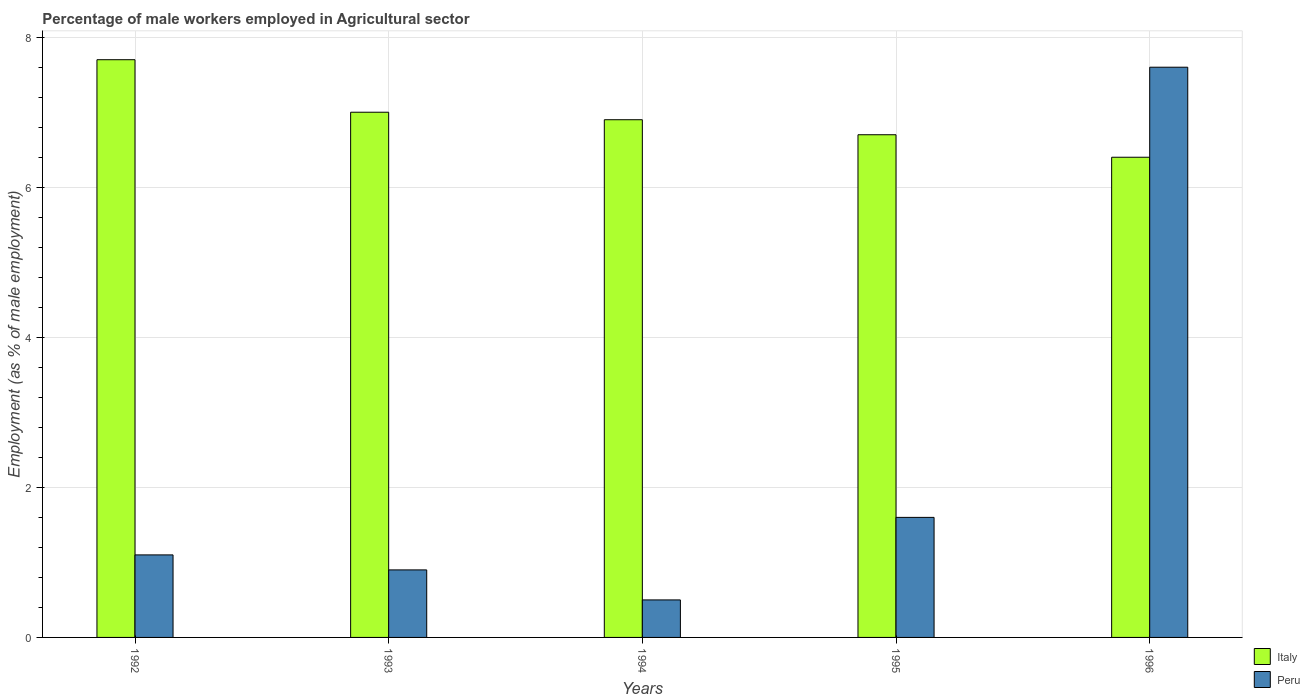How many different coloured bars are there?
Make the answer very short. 2. How many groups of bars are there?
Your response must be concise. 5. How many bars are there on the 4th tick from the left?
Offer a very short reply. 2. How many bars are there on the 4th tick from the right?
Offer a very short reply. 2. In how many cases, is the number of bars for a given year not equal to the number of legend labels?
Your answer should be compact. 0. Across all years, what is the maximum percentage of male workers employed in Agricultural sector in Italy?
Your response must be concise. 7.7. Across all years, what is the minimum percentage of male workers employed in Agricultural sector in Peru?
Give a very brief answer. 0.5. In which year was the percentage of male workers employed in Agricultural sector in Italy maximum?
Offer a very short reply. 1992. In which year was the percentage of male workers employed in Agricultural sector in Peru minimum?
Offer a terse response. 1994. What is the total percentage of male workers employed in Agricultural sector in Italy in the graph?
Ensure brevity in your answer.  34.7. What is the difference between the percentage of male workers employed in Agricultural sector in Peru in 1992 and that in 1994?
Make the answer very short. 0.6. What is the difference between the percentage of male workers employed in Agricultural sector in Italy in 1996 and the percentage of male workers employed in Agricultural sector in Peru in 1994?
Make the answer very short. 5.9. What is the average percentage of male workers employed in Agricultural sector in Peru per year?
Your answer should be very brief. 2.34. In the year 1993, what is the difference between the percentage of male workers employed in Agricultural sector in Peru and percentage of male workers employed in Agricultural sector in Italy?
Offer a terse response. -6.1. In how many years, is the percentage of male workers employed in Agricultural sector in Italy greater than 0.4 %?
Provide a succinct answer. 5. What is the ratio of the percentage of male workers employed in Agricultural sector in Peru in 1992 to that in 1996?
Make the answer very short. 0.14. What is the difference between the highest and the second highest percentage of male workers employed in Agricultural sector in Peru?
Your answer should be very brief. 6. What is the difference between the highest and the lowest percentage of male workers employed in Agricultural sector in Italy?
Your response must be concise. 1.3. What does the 1st bar from the right in 1992 represents?
Offer a terse response. Peru. Are all the bars in the graph horizontal?
Your response must be concise. No. How many years are there in the graph?
Provide a short and direct response. 5. Does the graph contain any zero values?
Your answer should be very brief. No. Where does the legend appear in the graph?
Provide a succinct answer. Bottom right. What is the title of the graph?
Provide a succinct answer. Percentage of male workers employed in Agricultural sector. Does "Portugal" appear as one of the legend labels in the graph?
Your answer should be very brief. No. What is the label or title of the X-axis?
Provide a short and direct response. Years. What is the label or title of the Y-axis?
Provide a succinct answer. Employment (as % of male employment). What is the Employment (as % of male employment) of Italy in 1992?
Your answer should be very brief. 7.7. What is the Employment (as % of male employment) in Peru in 1992?
Make the answer very short. 1.1. What is the Employment (as % of male employment) in Italy in 1993?
Give a very brief answer. 7. What is the Employment (as % of male employment) in Peru in 1993?
Make the answer very short. 0.9. What is the Employment (as % of male employment) in Italy in 1994?
Ensure brevity in your answer.  6.9. What is the Employment (as % of male employment) of Italy in 1995?
Your response must be concise. 6.7. What is the Employment (as % of male employment) in Peru in 1995?
Offer a terse response. 1.6. What is the Employment (as % of male employment) in Italy in 1996?
Ensure brevity in your answer.  6.4. What is the Employment (as % of male employment) of Peru in 1996?
Ensure brevity in your answer.  7.6. Across all years, what is the maximum Employment (as % of male employment) of Italy?
Your answer should be very brief. 7.7. Across all years, what is the maximum Employment (as % of male employment) in Peru?
Keep it short and to the point. 7.6. Across all years, what is the minimum Employment (as % of male employment) of Italy?
Your answer should be compact. 6.4. What is the total Employment (as % of male employment) in Italy in the graph?
Offer a terse response. 34.7. What is the total Employment (as % of male employment) of Peru in the graph?
Keep it short and to the point. 11.7. What is the difference between the Employment (as % of male employment) in Italy in 1992 and that in 1993?
Provide a succinct answer. 0.7. What is the difference between the Employment (as % of male employment) in Peru in 1992 and that in 1993?
Offer a very short reply. 0.2. What is the difference between the Employment (as % of male employment) of Italy in 1992 and that in 1994?
Your response must be concise. 0.8. What is the difference between the Employment (as % of male employment) of Peru in 1992 and that in 1994?
Keep it short and to the point. 0.6. What is the difference between the Employment (as % of male employment) in Peru in 1992 and that in 1996?
Provide a short and direct response. -6.5. What is the difference between the Employment (as % of male employment) in Peru in 1993 and that in 1995?
Provide a short and direct response. -0.7. What is the difference between the Employment (as % of male employment) of Italy in 1993 and that in 1996?
Your response must be concise. 0.6. What is the difference between the Employment (as % of male employment) in Italy in 1994 and that in 1995?
Provide a succinct answer. 0.2. What is the difference between the Employment (as % of male employment) in Italy in 1995 and that in 1996?
Ensure brevity in your answer.  0.3. What is the difference between the Employment (as % of male employment) in Peru in 1995 and that in 1996?
Your response must be concise. -6. What is the difference between the Employment (as % of male employment) in Italy in 1992 and the Employment (as % of male employment) in Peru in 1993?
Provide a succinct answer. 6.8. What is the difference between the Employment (as % of male employment) in Italy in 1992 and the Employment (as % of male employment) in Peru in 1996?
Make the answer very short. 0.1. What is the difference between the Employment (as % of male employment) in Italy in 1993 and the Employment (as % of male employment) in Peru in 1994?
Your response must be concise. 6.5. What is the difference between the Employment (as % of male employment) in Italy in 1993 and the Employment (as % of male employment) in Peru in 1996?
Provide a succinct answer. -0.6. What is the difference between the Employment (as % of male employment) of Italy in 1994 and the Employment (as % of male employment) of Peru in 1995?
Provide a succinct answer. 5.3. What is the average Employment (as % of male employment) of Italy per year?
Provide a short and direct response. 6.94. What is the average Employment (as % of male employment) of Peru per year?
Offer a terse response. 2.34. In the year 1992, what is the difference between the Employment (as % of male employment) in Italy and Employment (as % of male employment) in Peru?
Keep it short and to the point. 6.6. In the year 1994, what is the difference between the Employment (as % of male employment) in Italy and Employment (as % of male employment) in Peru?
Offer a very short reply. 6.4. In the year 1995, what is the difference between the Employment (as % of male employment) in Italy and Employment (as % of male employment) in Peru?
Offer a terse response. 5.1. In the year 1996, what is the difference between the Employment (as % of male employment) in Italy and Employment (as % of male employment) in Peru?
Keep it short and to the point. -1.2. What is the ratio of the Employment (as % of male employment) of Italy in 1992 to that in 1993?
Your response must be concise. 1.1. What is the ratio of the Employment (as % of male employment) in Peru in 1992 to that in 1993?
Your answer should be compact. 1.22. What is the ratio of the Employment (as % of male employment) of Italy in 1992 to that in 1994?
Ensure brevity in your answer.  1.12. What is the ratio of the Employment (as % of male employment) in Peru in 1992 to that in 1994?
Offer a very short reply. 2.2. What is the ratio of the Employment (as % of male employment) in Italy in 1992 to that in 1995?
Provide a succinct answer. 1.15. What is the ratio of the Employment (as % of male employment) in Peru in 1992 to that in 1995?
Provide a succinct answer. 0.69. What is the ratio of the Employment (as % of male employment) of Italy in 1992 to that in 1996?
Keep it short and to the point. 1.2. What is the ratio of the Employment (as % of male employment) of Peru in 1992 to that in 1996?
Your answer should be compact. 0.14. What is the ratio of the Employment (as % of male employment) of Italy in 1993 to that in 1994?
Offer a terse response. 1.01. What is the ratio of the Employment (as % of male employment) in Italy in 1993 to that in 1995?
Keep it short and to the point. 1.04. What is the ratio of the Employment (as % of male employment) of Peru in 1993 to that in 1995?
Your response must be concise. 0.56. What is the ratio of the Employment (as % of male employment) of Italy in 1993 to that in 1996?
Offer a terse response. 1.09. What is the ratio of the Employment (as % of male employment) in Peru in 1993 to that in 1996?
Offer a terse response. 0.12. What is the ratio of the Employment (as % of male employment) in Italy in 1994 to that in 1995?
Provide a short and direct response. 1.03. What is the ratio of the Employment (as % of male employment) of Peru in 1994 to that in 1995?
Make the answer very short. 0.31. What is the ratio of the Employment (as % of male employment) in Italy in 1994 to that in 1996?
Keep it short and to the point. 1.08. What is the ratio of the Employment (as % of male employment) of Peru in 1994 to that in 1996?
Offer a very short reply. 0.07. What is the ratio of the Employment (as % of male employment) of Italy in 1995 to that in 1996?
Ensure brevity in your answer.  1.05. What is the ratio of the Employment (as % of male employment) in Peru in 1995 to that in 1996?
Provide a short and direct response. 0.21. What is the difference between the highest and the lowest Employment (as % of male employment) in Italy?
Provide a short and direct response. 1.3. What is the difference between the highest and the lowest Employment (as % of male employment) in Peru?
Your response must be concise. 7.1. 